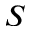Convert formula to latex. <formula><loc_0><loc_0><loc_500><loc_500>S</formula> 